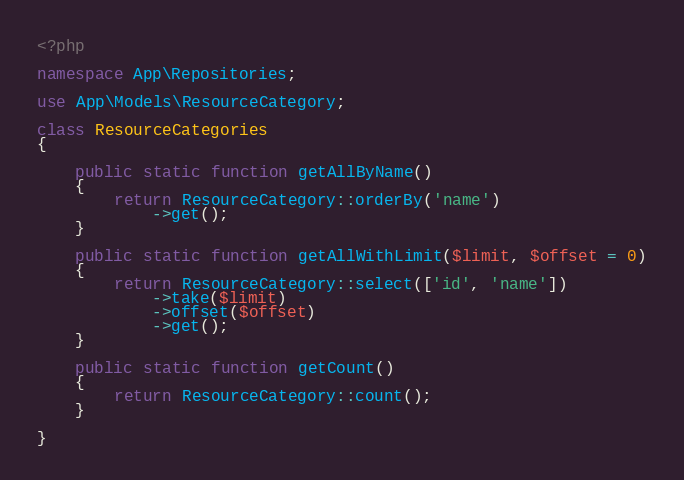<code> <loc_0><loc_0><loc_500><loc_500><_PHP_><?php

namespace App\Repositories;

use App\Models\ResourceCategory;

class ResourceCategories
{

    public static function getAllByName()
    {
        return ResourceCategory::orderBy('name')
            ->get();
    }

    public static function getAllWithLimit($limit, $offset = 0)
    {
        return ResourceCategory::select(['id', 'name'])
            ->take($limit)
            ->offset($offset)
            ->get();
    }

    public static function getCount()
    {
        return ResourceCategory::count();
    }

}</code> 